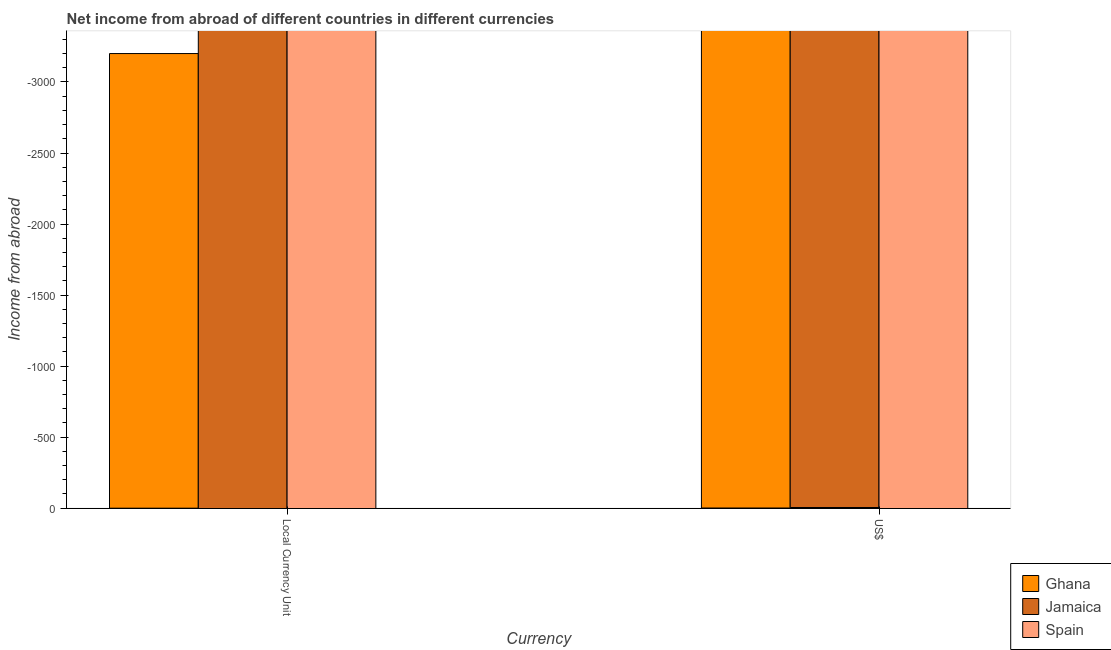Are the number of bars per tick equal to the number of legend labels?
Make the answer very short. No. Are the number of bars on each tick of the X-axis equal?
Provide a succinct answer. Yes. How many bars are there on the 2nd tick from the left?
Offer a very short reply. 0. How many bars are there on the 2nd tick from the right?
Offer a terse response. 0. What is the label of the 2nd group of bars from the left?
Provide a succinct answer. US$. What is the income from abroad in us$ in Jamaica?
Offer a terse response. 0. Across all countries, what is the minimum income from abroad in us$?
Your answer should be compact. 0. What is the average income from abroad in us$ per country?
Offer a very short reply. 0. In how many countries, is the income from abroad in us$ greater than the average income from abroad in us$ taken over all countries?
Provide a succinct answer. 0. How many bars are there?
Make the answer very short. 0. Are all the bars in the graph horizontal?
Your response must be concise. No. What is the difference between two consecutive major ticks on the Y-axis?
Offer a very short reply. 500. Where does the legend appear in the graph?
Keep it short and to the point. Bottom right. How many legend labels are there?
Your answer should be compact. 3. What is the title of the graph?
Give a very brief answer. Net income from abroad of different countries in different currencies. Does "Marshall Islands" appear as one of the legend labels in the graph?
Provide a succinct answer. No. What is the label or title of the X-axis?
Provide a succinct answer. Currency. What is the label or title of the Y-axis?
Give a very brief answer. Income from abroad. What is the Income from abroad of Jamaica in Local Currency Unit?
Keep it short and to the point. 0. What is the Income from abroad in Spain in Local Currency Unit?
Your answer should be compact. 0. What is the Income from abroad in Jamaica in US$?
Offer a very short reply. 0. What is the total Income from abroad in Jamaica in the graph?
Your answer should be very brief. 0. What is the average Income from abroad in Ghana per Currency?
Your answer should be very brief. 0. 